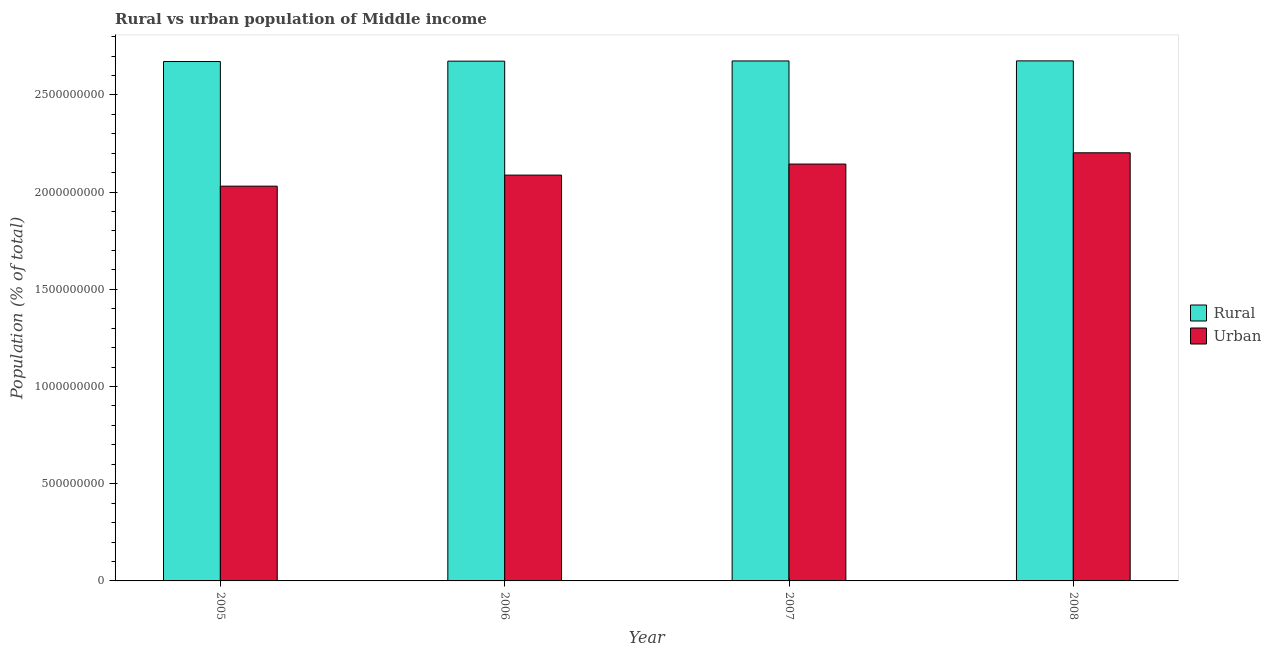How many different coloured bars are there?
Offer a terse response. 2. How many groups of bars are there?
Provide a short and direct response. 4. Are the number of bars per tick equal to the number of legend labels?
Offer a terse response. Yes. What is the rural population density in 2008?
Provide a short and direct response. 2.68e+09. Across all years, what is the maximum urban population density?
Give a very brief answer. 2.20e+09. Across all years, what is the minimum rural population density?
Offer a very short reply. 2.67e+09. What is the total urban population density in the graph?
Offer a very short reply. 8.46e+09. What is the difference between the rural population density in 2005 and that in 2006?
Your response must be concise. -1.94e+06. What is the difference between the rural population density in 2006 and the urban population density in 2008?
Make the answer very short. -1.40e+06. What is the average urban population density per year?
Your response must be concise. 2.12e+09. In the year 2005, what is the difference between the rural population density and urban population density?
Give a very brief answer. 0. What is the ratio of the urban population density in 2005 to that in 2007?
Your answer should be compact. 0.95. Is the urban population density in 2006 less than that in 2007?
Your response must be concise. Yes. Is the difference between the urban population density in 2005 and 2006 greater than the difference between the rural population density in 2005 and 2006?
Keep it short and to the point. No. What is the difference between the highest and the second highest urban population density?
Your answer should be very brief. 5.79e+07. What is the difference between the highest and the lowest rural population density?
Give a very brief answer. 3.34e+06. What does the 1st bar from the left in 2008 represents?
Keep it short and to the point. Rural. What does the 2nd bar from the right in 2005 represents?
Give a very brief answer. Rural. Are all the bars in the graph horizontal?
Make the answer very short. No. How many years are there in the graph?
Your answer should be very brief. 4. What is the difference between two consecutive major ticks on the Y-axis?
Offer a terse response. 5.00e+08. Does the graph contain grids?
Make the answer very short. No. Where does the legend appear in the graph?
Your response must be concise. Center right. How are the legend labels stacked?
Offer a very short reply. Vertical. What is the title of the graph?
Give a very brief answer. Rural vs urban population of Middle income. What is the label or title of the Y-axis?
Give a very brief answer. Population (% of total). What is the Population (% of total) of Rural in 2005?
Give a very brief answer. 2.67e+09. What is the Population (% of total) of Urban in 2005?
Provide a succinct answer. 2.03e+09. What is the Population (% of total) of Rural in 2006?
Offer a terse response. 2.67e+09. What is the Population (% of total) in Urban in 2006?
Keep it short and to the point. 2.09e+09. What is the Population (% of total) of Rural in 2007?
Keep it short and to the point. 2.67e+09. What is the Population (% of total) in Urban in 2007?
Your answer should be compact. 2.14e+09. What is the Population (% of total) of Rural in 2008?
Offer a very short reply. 2.68e+09. What is the Population (% of total) of Urban in 2008?
Provide a succinct answer. 2.20e+09. Across all years, what is the maximum Population (% of total) of Rural?
Your answer should be compact. 2.68e+09. Across all years, what is the maximum Population (% of total) in Urban?
Keep it short and to the point. 2.20e+09. Across all years, what is the minimum Population (% of total) of Rural?
Your answer should be very brief. 2.67e+09. Across all years, what is the minimum Population (% of total) of Urban?
Provide a succinct answer. 2.03e+09. What is the total Population (% of total) of Rural in the graph?
Your response must be concise. 1.07e+1. What is the total Population (% of total) of Urban in the graph?
Your response must be concise. 8.46e+09. What is the difference between the Population (% of total) of Rural in 2005 and that in 2006?
Your answer should be compact. -1.94e+06. What is the difference between the Population (% of total) in Urban in 2005 and that in 2006?
Keep it short and to the point. -5.68e+07. What is the difference between the Population (% of total) of Rural in 2005 and that in 2007?
Your response must be concise. -2.99e+06. What is the difference between the Population (% of total) in Urban in 2005 and that in 2007?
Give a very brief answer. -1.14e+08. What is the difference between the Population (% of total) of Rural in 2005 and that in 2008?
Your answer should be very brief. -3.34e+06. What is the difference between the Population (% of total) in Urban in 2005 and that in 2008?
Provide a short and direct response. -1.72e+08. What is the difference between the Population (% of total) of Rural in 2006 and that in 2007?
Make the answer very short. -1.04e+06. What is the difference between the Population (% of total) of Urban in 2006 and that in 2007?
Offer a very short reply. -5.69e+07. What is the difference between the Population (% of total) of Rural in 2006 and that in 2008?
Keep it short and to the point. -1.40e+06. What is the difference between the Population (% of total) in Urban in 2006 and that in 2008?
Make the answer very short. -1.15e+08. What is the difference between the Population (% of total) of Rural in 2007 and that in 2008?
Offer a very short reply. -3.52e+05. What is the difference between the Population (% of total) in Urban in 2007 and that in 2008?
Give a very brief answer. -5.79e+07. What is the difference between the Population (% of total) in Rural in 2005 and the Population (% of total) in Urban in 2006?
Ensure brevity in your answer.  5.84e+08. What is the difference between the Population (% of total) of Rural in 2005 and the Population (% of total) of Urban in 2007?
Provide a short and direct response. 5.27e+08. What is the difference between the Population (% of total) of Rural in 2005 and the Population (% of total) of Urban in 2008?
Keep it short and to the point. 4.69e+08. What is the difference between the Population (% of total) of Rural in 2006 and the Population (% of total) of Urban in 2007?
Provide a succinct answer. 5.29e+08. What is the difference between the Population (% of total) of Rural in 2006 and the Population (% of total) of Urban in 2008?
Provide a short and direct response. 4.71e+08. What is the difference between the Population (% of total) in Rural in 2007 and the Population (% of total) in Urban in 2008?
Provide a succinct answer. 4.72e+08. What is the average Population (% of total) in Rural per year?
Make the answer very short. 2.67e+09. What is the average Population (% of total) of Urban per year?
Your answer should be very brief. 2.12e+09. In the year 2005, what is the difference between the Population (% of total) of Rural and Population (% of total) of Urban?
Your response must be concise. 6.41e+08. In the year 2006, what is the difference between the Population (% of total) of Rural and Population (% of total) of Urban?
Offer a very short reply. 5.86e+08. In the year 2007, what is the difference between the Population (% of total) of Rural and Population (% of total) of Urban?
Provide a short and direct response. 5.30e+08. In the year 2008, what is the difference between the Population (% of total) in Rural and Population (% of total) in Urban?
Offer a very short reply. 4.73e+08. What is the ratio of the Population (% of total) of Rural in 2005 to that in 2006?
Ensure brevity in your answer.  1. What is the ratio of the Population (% of total) in Urban in 2005 to that in 2006?
Your response must be concise. 0.97. What is the ratio of the Population (% of total) in Rural in 2005 to that in 2007?
Offer a very short reply. 1. What is the ratio of the Population (% of total) of Urban in 2005 to that in 2007?
Keep it short and to the point. 0.95. What is the ratio of the Population (% of total) in Urban in 2005 to that in 2008?
Provide a succinct answer. 0.92. What is the ratio of the Population (% of total) in Rural in 2006 to that in 2007?
Provide a short and direct response. 1. What is the ratio of the Population (% of total) of Urban in 2006 to that in 2007?
Keep it short and to the point. 0.97. What is the ratio of the Population (% of total) in Urban in 2006 to that in 2008?
Offer a terse response. 0.95. What is the ratio of the Population (% of total) in Urban in 2007 to that in 2008?
Ensure brevity in your answer.  0.97. What is the difference between the highest and the second highest Population (% of total) of Rural?
Provide a succinct answer. 3.52e+05. What is the difference between the highest and the second highest Population (% of total) of Urban?
Your response must be concise. 5.79e+07. What is the difference between the highest and the lowest Population (% of total) of Rural?
Keep it short and to the point. 3.34e+06. What is the difference between the highest and the lowest Population (% of total) of Urban?
Your answer should be compact. 1.72e+08. 